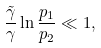<formula> <loc_0><loc_0><loc_500><loc_500>\frac { \tilde { \gamma } } \gamma \ln \frac { p _ { 1 } } { p _ { 2 } } \ll 1 ,</formula> 